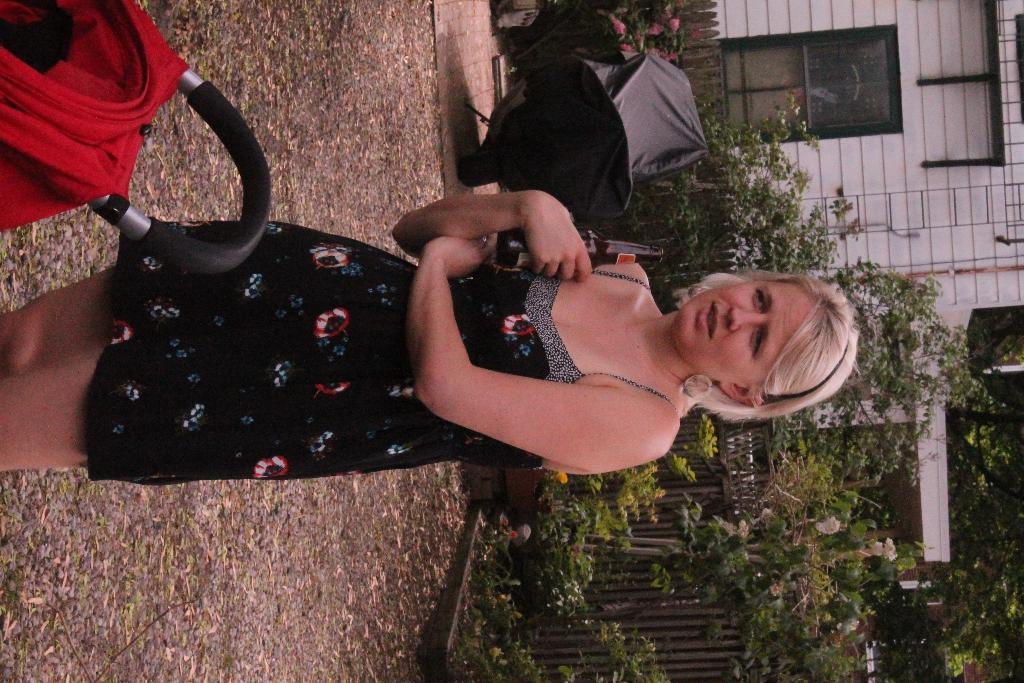Describe this image in one or two sentences. In this picture in the front there is a woman standing and holding a bottle in her hand. On the right side there are plants, trees and there is a wooden fence and there is a house. In the center there is an object which is black in colour. On the left side there is a trolley which is red in colour and there is a black colour handle on the trolley. 